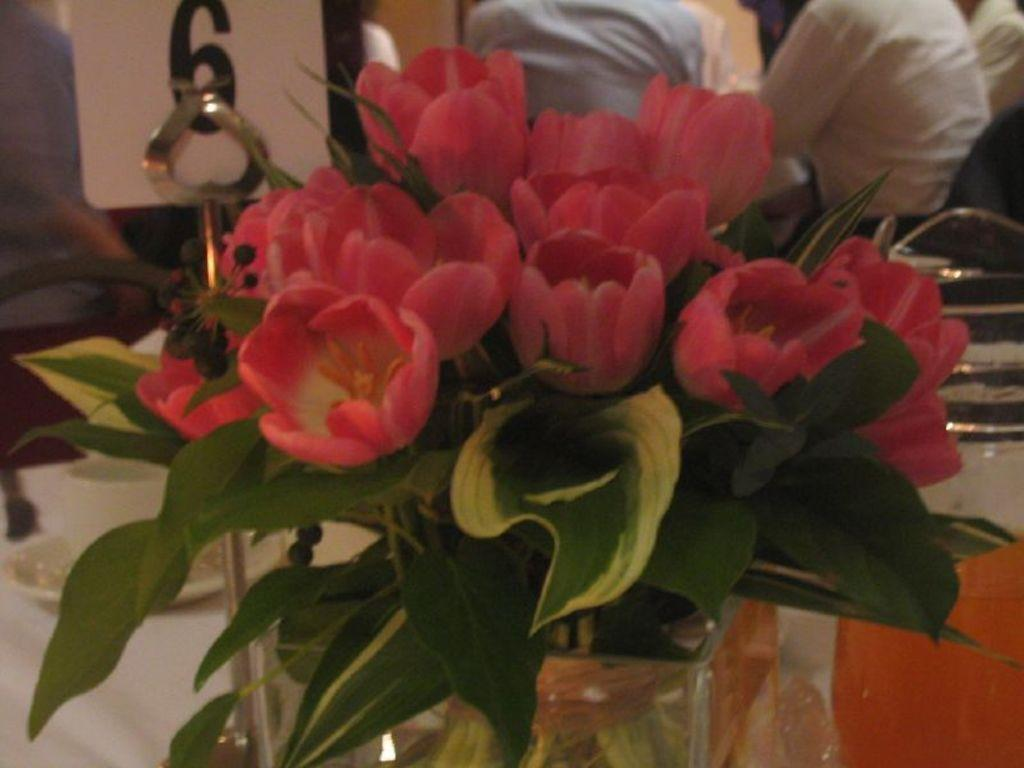What type of plants can be seen in the image? There are flowers and leaves visible in the image. What is located at the bottom of the image? There is cloth and a rod stand at the bottom of the image. Can you describe the background of the image? There are people, a board, and other items visible in the background of the image. What type of locket can be seen hanging from the flowers in the image? There is no locket present in the image; it features flowers, leaves, and other objects. Can you describe the fight that is happening in the background of the image? There is no fight depicted in the image; it shows people, a board, and other items in the background. 